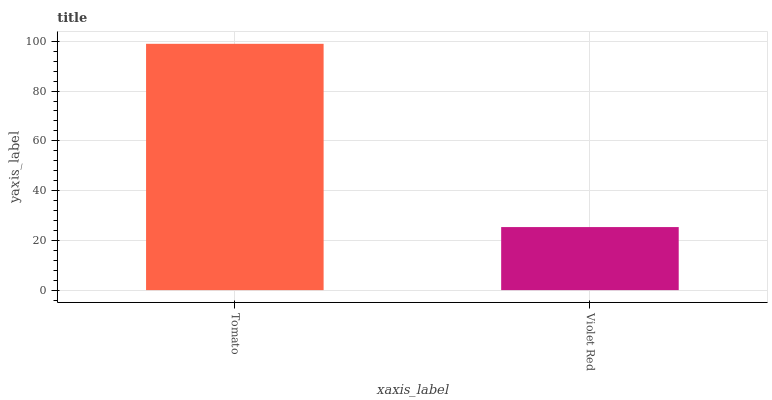Is Violet Red the minimum?
Answer yes or no. Yes. Is Tomato the maximum?
Answer yes or no. Yes. Is Violet Red the maximum?
Answer yes or no. No. Is Tomato greater than Violet Red?
Answer yes or no. Yes. Is Violet Red less than Tomato?
Answer yes or no. Yes. Is Violet Red greater than Tomato?
Answer yes or no. No. Is Tomato less than Violet Red?
Answer yes or no. No. Is Tomato the high median?
Answer yes or no. Yes. Is Violet Red the low median?
Answer yes or no. Yes. Is Violet Red the high median?
Answer yes or no. No. Is Tomato the low median?
Answer yes or no. No. 